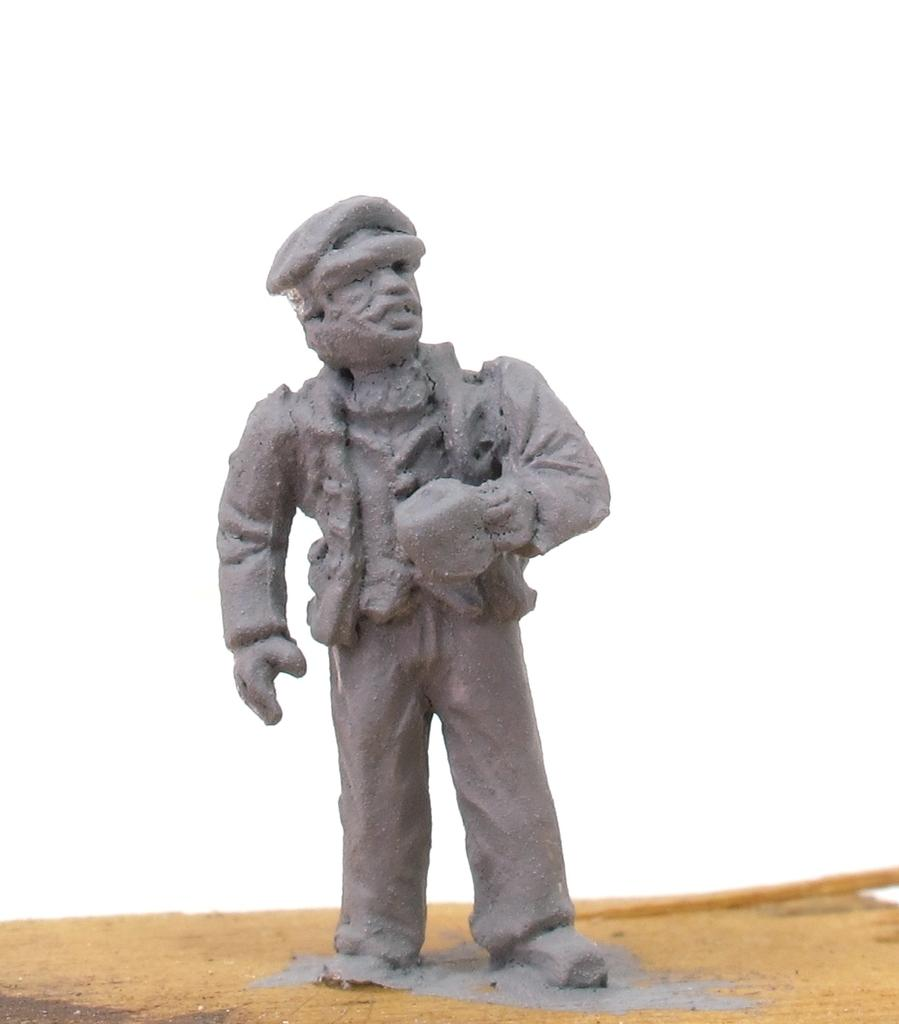What is the main subject in the foreground of the image? There is a clay statue in the foreground of the image. What color is the background of the image? The background of the image is white. What type of gun is being used in the image? There is no gun present in the image; it features a clay statue in the foreground and a white background. 